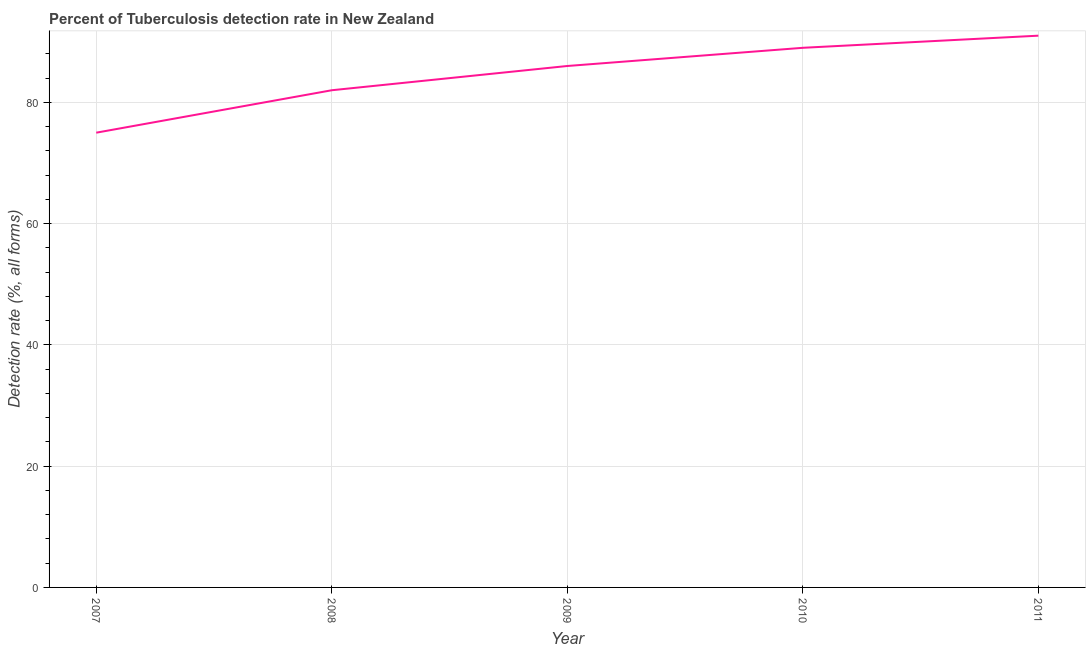What is the detection rate of tuberculosis in 2010?
Provide a succinct answer. 89. Across all years, what is the maximum detection rate of tuberculosis?
Give a very brief answer. 91. Across all years, what is the minimum detection rate of tuberculosis?
Your answer should be compact. 75. In which year was the detection rate of tuberculosis maximum?
Your answer should be very brief. 2011. In which year was the detection rate of tuberculosis minimum?
Your response must be concise. 2007. What is the sum of the detection rate of tuberculosis?
Your response must be concise. 423. What is the difference between the detection rate of tuberculosis in 2009 and 2011?
Your answer should be very brief. -5. What is the average detection rate of tuberculosis per year?
Ensure brevity in your answer.  84.6. In how many years, is the detection rate of tuberculosis greater than 80 %?
Your answer should be very brief. 4. Do a majority of the years between 2007 and 2008 (inclusive) have detection rate of tuberculosis greater than 20 %?
Offer a very short reply. Yes. What is the ratio of the detection rate of tuberculosis in 2009 to that in 2011?
Ensure brevity in your answer.  0.95. Is the detection rate of tuberculosis in 2007 less than that in 2008?
Make the answer very short. Yes. What is the difference between the highest and the second highest detection rate of tuberculosis?
Provide a succinct answer. 2. What is the difference between the highest and the lowest detection rate of tuberculosis?
Give a very brief answer. 16. Does the detection rate of tuberculosis monotonically increase over the years?
Ensure brevity in your answer.  Yes. How many years are there in the graph?
Keep it short and to the point. 5. What is the difference between two consecutive major ticks on the Y-axis?
Keep it short and to the point. 20. Are the values on the major ticks of Y-axis written in scientific E-notation?
Make the answer very short. No. Does the graph contain grids?
Keep it short and to the point. Yes. What is the title of the graph?
Provide a short and direct response. Percent of Tuberculosis detection rate in New Zealand. What is the label or title of the X-axis?
Your answer should be compact. Year. What is the label or title of the Y-axis?
Provide a short and direct response. Detection rate (%, all forms). What is the Detection rate (%, all forms) of 2007?
Make the answer very short. 75. What is the Detection rate (%, all forms) in 2008?
Offer a very short reply. 82. What is the Detection rate (%, all forms) in 2009?
Provide a short and direct response. 86. What is the Detection rate (%, all forms) in 2010?
Provide a short and direct response. 89. What is the Detection rate (%, all forms) in 2011?
Make the answer very short. 91. What is the difference between the Detection rate (%, all forms) in 2007 and 2008?
Your answer should be very brief. -7. What is the difference between the Detection rate (%, all forms) in 2007 and 2010?
Ensure brevity in your answer.  -14. What is the difference between the Detection rate (%, all forms) in 2008 and 2009?
Make the answer very short. -4. What is the difference between the Detection rate (%, all forms) in 2009 and 2010?
Make the answer very short. -3. What is the difference between the Detection rate (%, all forms) in 2010 and 2011?
Offer a very short reply. -2. What is the ratio of the Detection rate (%, all forms) in 2007 to that in 2008?
Make the answer very short. 0.92. What is the ratio of the Detection rate (%, all forms) in 2007 to that in 2009?
Provide a short and direct response. 0.87. What is the ratio of the Detection rate (%, all forms) in 2007 to that in 2010?
Make the answer very short. 0.84. What is the ratio of the Detection rate (%, all forms) in 2007 to that in 2011?
Make the answer very short. 0.82. What is the ratio of the Detection rate (%, all forms) in 2008 to that in 2009?
Provide a succinct answer. 0.95. What is the ratio of the Detection rate (%, all forms) in 2008 to that in 2010?
Your answer should be compact. 0.92. What is the ratio of the Detection rate (%, all forms) in 2008 to that in 2011?
Your answer should be very brief. 0.9. What is the ratio of the Detection rate (%, all forms) in 2009 to that in 2011?
Your answer should be very brief. 0.94. What is the ratio of the Detection rate (%, all forms) in 2010 to that in 2011?
Keep it short and to the point. 0.98. 